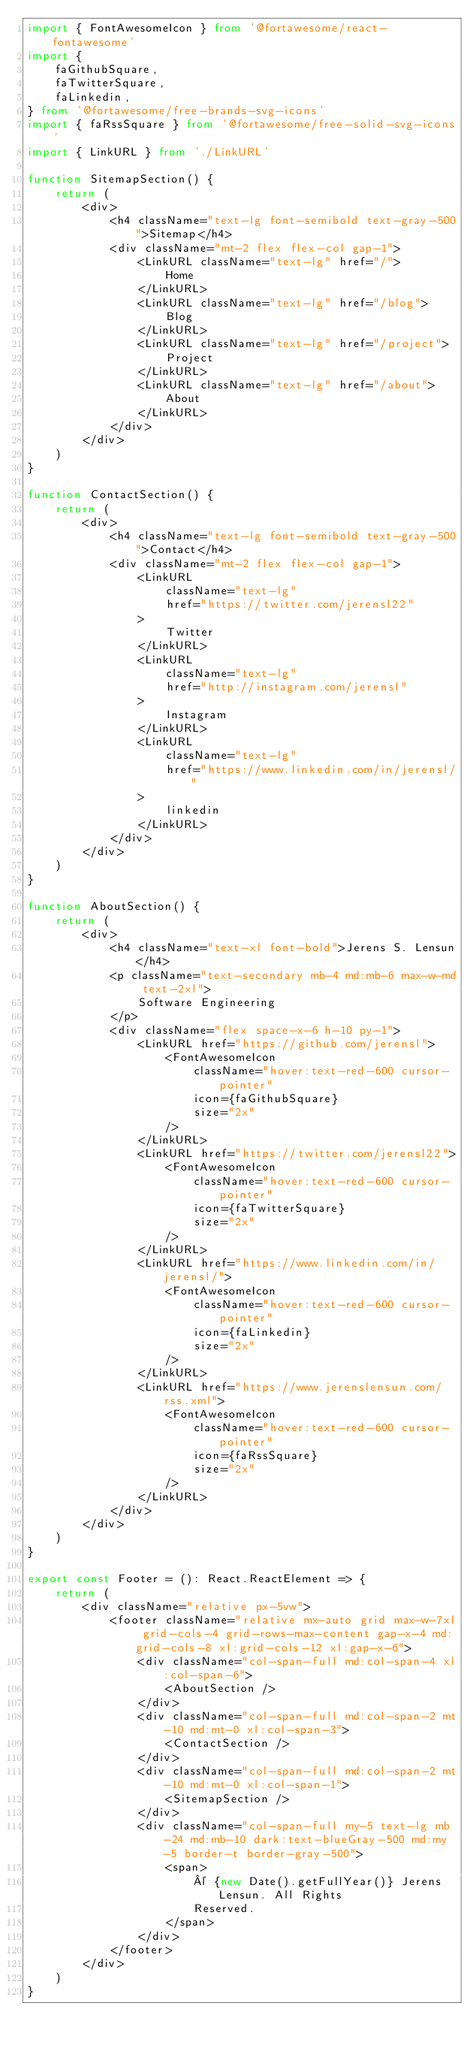<code> <loc_0><loc_0><loc_500><loc_500><_TypeScript_>import { FontAwesomeIcon } from '@fortawesome/react-fontawesome'
import {
    faGithubSquare,
    faTwitterSquare,
    faLinkedin,
} from '@fortawesome/free-brands-svg-icons'
import { faRssSquare } from '@fortawesome/free-solid-svg-icons'
import { LinkURL } from './LinkURL'

function SitemapSection() {
    return (
        <div>
            <h4 className="text-lg font-semibold text-gray-500">Sitemap</h4>
            <div className="mt-2 flex flex-col gap-1">
                <LinkURL className="text-lg" href="/">
                    Home
                </LinkURL>
                <LinkURL className="text-lg" href="/blog">
                    Blog
                </LinkURL>
                <LinkURL className="text-lg" href="/project">
                    Project
                </LinkURL>
                <LinkURL className="text-lg" href="/about">
                    About
                </LinkURL>
            </div>
        </div>
    )
}

function ContactSection() {
    return (
        <div>
            <h4 className="text-lg font-semibold text-gray-500">Contact</h4>
            <div className="mt-2 flex flex-col gap-1">
                <LinkURL
                    className="text-lg"
                    href="https://twitter.com/jerensl22"
                >
                    Twitter
                </LinkURL>
                <LinkURL
                    className="text-lg"
                    href="http://instagram.com/jerensl"
                >
                    Instagram
                </LinkURL>
                <LinkURL
                    className="text-lg"
                    href="https://www.linkedin.com/in/jerensl/"
                >
                    linkedin
                </LinkURL>
            </div>
        </div>
    )
}

function AboutSection() {
    return (
        <div>
            <h4 className="text-xl font-bold">Jerens S. Lensun</h4>
            <p className="text-secondary mb-4 md:mb-6 max-w-md text-2xl">
                Software Engineering
            </p>
            <div className="flex space-x-6 h-10 py-1">
                <LinkURL href="https://github.com/jerensl">
                    <FontAwesomeIcon
                        className="hover:text-red-600 cursor-pointer"
                        icon={faGithubSquare}
                        size="2x"
                    />
                </LinkURL>
                <LinkURL href="https://twitter.com/jerensl22">
                    <FontAwesomeIcon
                        className="hover:text-red-600 cursor-pointer"
                        icon={faTwitterSquare}
                        size="2x"
                    />
                </LinkURL>
                <LinkURL href="https://www.linkedin.com/in/jerensl/">
                    <FontAwesomeIcon
                        className="hover:text-red-600 cursor-pointer"
                        icon={faLinkedin}
                        size="2x"
                    />
                </LinkURL>
                <LinkURL href="https://www.jerenslensun.com/rss.xml">
                    <FontAwesomeIcon
                        className="hover:text-red-600 cursor-pointer"
                        icon={faRssSquare}
                        size="2x"
                    />
                </LinkURL>
            </div>
        </div>
    )
}

export const Footer = (): React.ReactElement => {
    return (
        <div className="relative px-5vw">
            <footer className="relative mx-auto grid max-w-7xl grid-cols-4 grid-rows-max-content gap-x-4 md:grid-cols-8 xl:grid-cols-12 xl:gap-x-6">
                <div className="col-span-full md:col-span-4 xl:col-span-6">
                    <AboutSection />
                </div>
                <div className="col-span-full md:col-span-2 mt-10 md:mt-0 xl:col-span-3">
                    <ContactSection />
                </div>
                <div className="col-span-full md:col-span-2 mt-10 md:mt-0 xl:col-span-1">
                    <SitemapSection />
                </div>
                <div className="col-span-full my-5 text-lg mb-24 md:mb-10 dark:text-blueGray-500 md:my-5 border-t border-gray-500">
                    <span>
                        © {new Date().getFullYear()} Jerens Lensun. All Rights
                        Reserved.
                    </span>
                </div>
            </footer>
        </div>
    )
}
</code> 